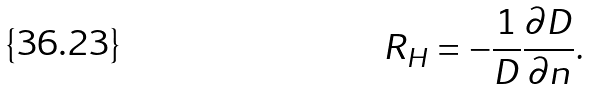Convert formula to latex. <formula><loc_0><loc_0><loc_500><loc_500>R _ { H } = - \frac { 1 } { D } \frac { \partial D } { \partial n } .</formula> 